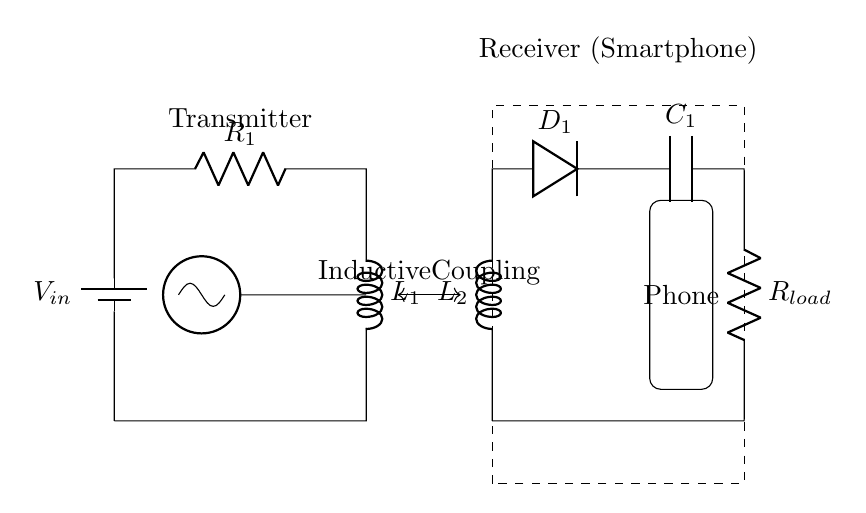What is the input voltage in this circuit? The input voltage is represented by the battery symbol labeled V_in. This indicates the potential difference supplied to the circuit.
Answer: V_in What component is used for inductive coupling? The inductive coupling is established between the two coils marked L_1 and L_2, indicated by the arrow connecting them.
Answer: L_1 and L_2 What is the function of the oscillator in the circuit? The oscillator generates an alternating current that is necessary for the inductive coupling to transfer energy wirelessly between the primary and secondary coils.
Answer: Generating AC How many resistors are present in the circuit? The circuit diagram shows one resistor labeled R_1 connected in the transmitter section, which is used to manage current flow.
Answer: One Which component rectifies the output in the receiver section? The diode marked D_1 is responsible for rectifying the alternating current produced by the inductive coupling into direct current for the load.
Answer: D_1 What is the purpose of the capacitor in the circuit? The capacitor labeled C_1 smoothens the output current by storing and releasing energy, ensuring a steady flow to the load.
Answer: Smoothing output What does the dashed rectangle represent in the circuit diagram? The dashed rectangle signifies the physical boundary of the receiver part of the circuit, which includes the smartphone receiving the wireless charge.
Answer: Receiver area 